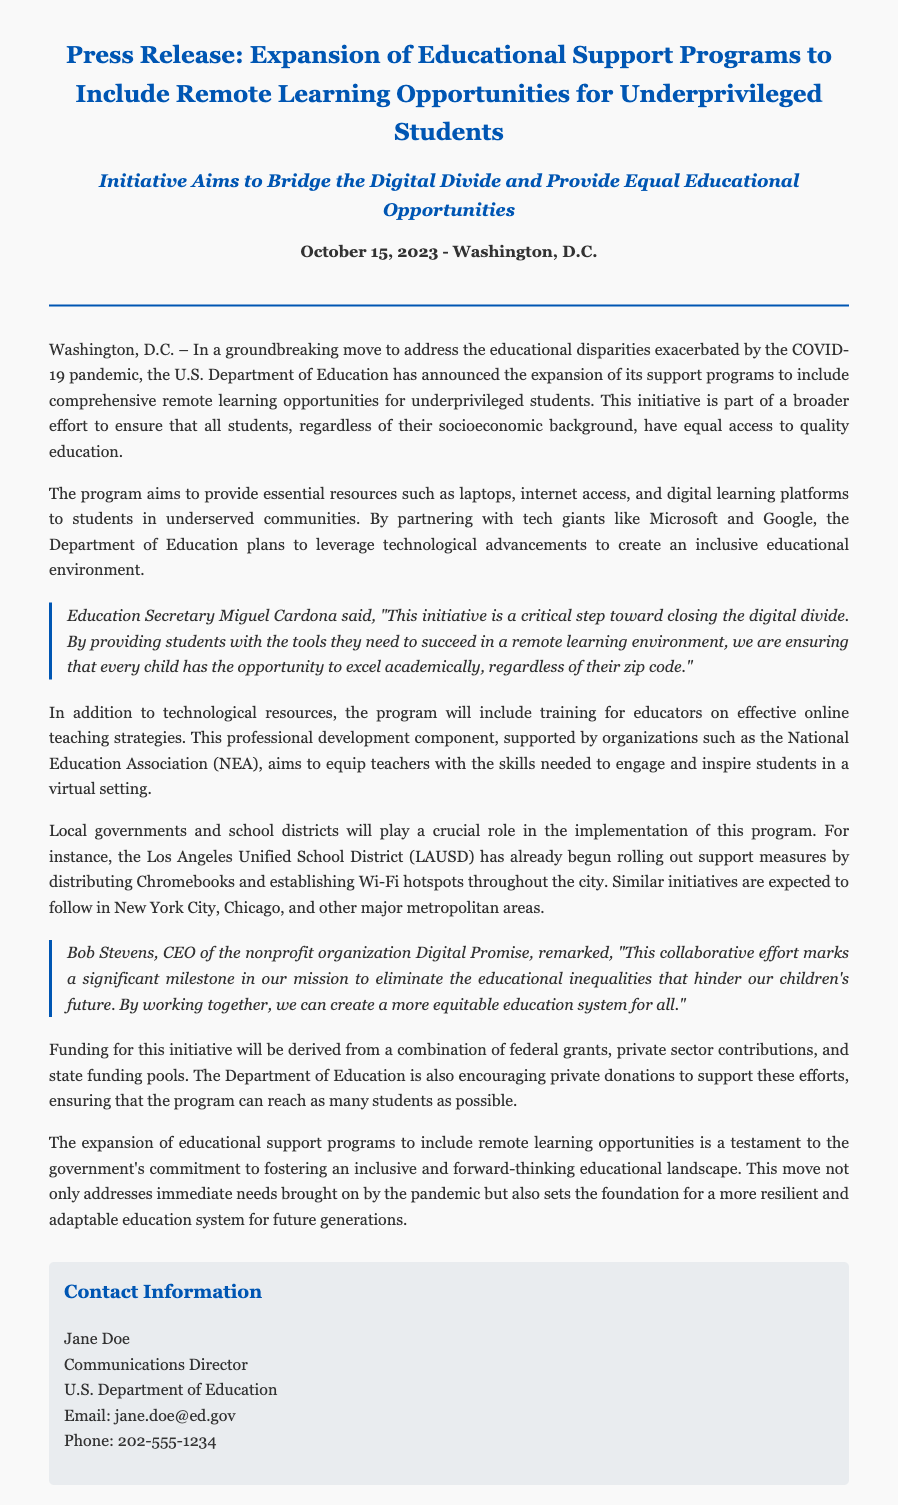What is the date of the press release? The date of the press release is mentioned at the beginning of the document.
Answer: October 15, 2023 Who announced the expansion of the educational support programs? The announcement is made by a specific government department, mentioned in the text.
Answer: U.S. Department of Education What is the primary goal of the initiative? The primary goal is clearly stated in the document regarding educational disparities.
Answer: Bridge the digital divide Which tech companies are partnering with the Department of Education? The document lists two specific tech companies involved in the initiative.
Answer: Microsoft and Google What resources are being provided to students in underserved communities? The document specifies the types of resources included in the program.
Answer: Laptops and internet access Who is the Education Secretary quoted in the press release? The name of the Education Secretary is mentioned in the document.
Answer: Miguel Cardona Which district has started rolling out support measures by distributing Chromebooks? The document provides the name of a school district taking early action on this initiative.
Answer: Los Angeles Unified School District (LAUSD) What entities are contributing funding for the initiative? The document mentions various sources of funding for the program.
Answer: Federal grants, private sector contributions, and state funding pools What training is included in the program for educators? The document discusses a specific aspect related to training for educators involved in the initiative.
Answer: Online teaching strategies 